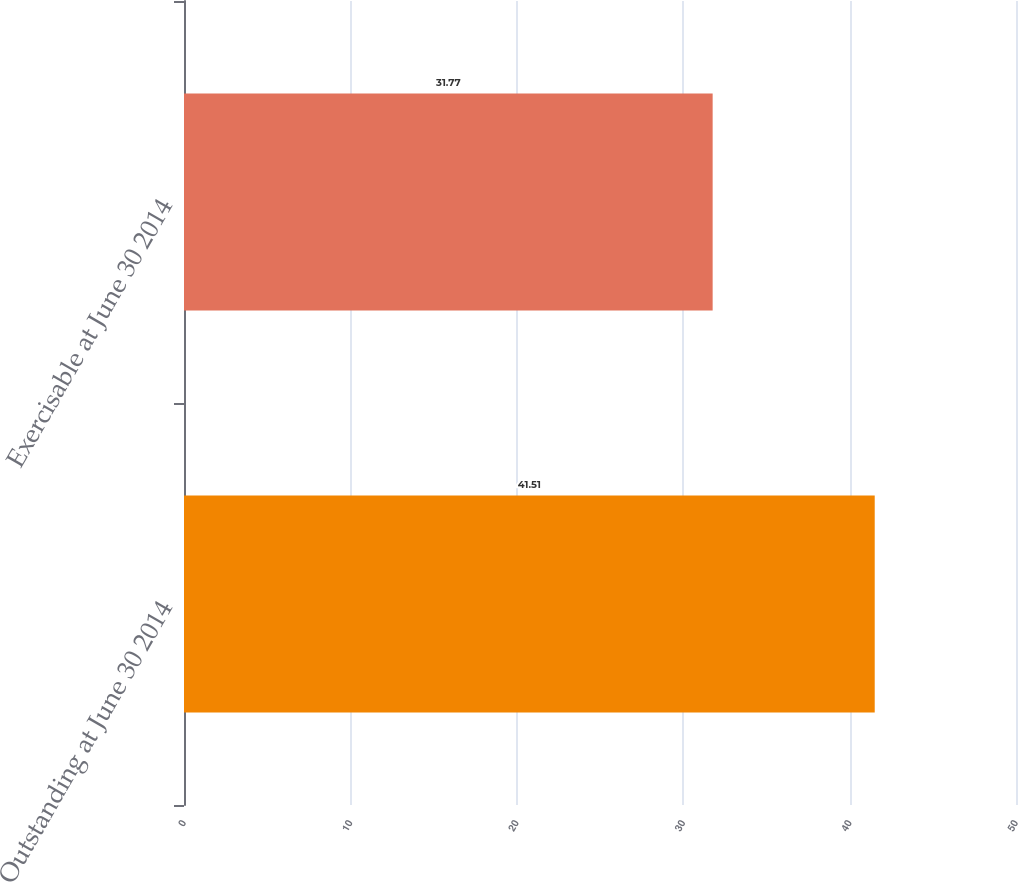Convert chart. <chart><loc_0><loc_0><loc_500><loc_500><bar_chart><fcel>Outstanding at June 30 2014<fcel>Exercisable at June 30 2014<nl><fcel>41.51<fcel>31.77<nl></chart> 